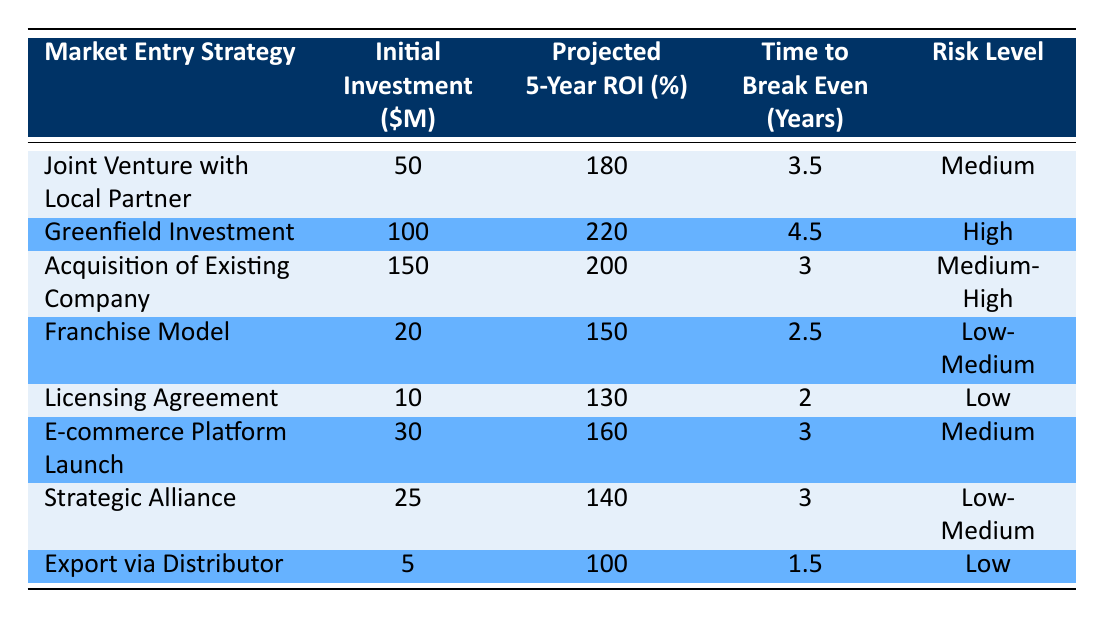What is the initial investment for a Joint Venture with Local Partner? The table shows that the initial investment for a Joint Venture with Local Partner is listed in the "Initial Investment ($M)" column, which states $50 million.
Answer: 50 million What is the projected ROI for the Greenfield Investment strategy? Referring to the "Projected 5-Year ROI (%)" column, the Greenfield Investment strategy has a projected ROI of 220%.
Answer: 220% Which market entry strategy has the lowest initial investment? By comparing the "Initial Investment ($M)" values across all strategies, the Export via Distributor has the lowest investment at $5 million.
Answer: Export via Distributor Is the time to break even for the Franchise Model less than 3 years? The time to break even for the Franchise Model is 2.5 years, which is indeed less than 3 years.
Answer: Yes What is the average projected ROI for all the strategies listed? To find the average projected ROI, we sum the projected ROIs: (180 + 220 + 200 + 150 + 130 + 160 + 140 + 100) = 1280, then divide by the number of strategies, which is 8: 1280 / 8 = 160.
Answer: 160 How many strategies have a risk level categorized as "Medium"? Looking through the "Risk Level" column, we find that two strategies, Joint Venture with Local Partner and E-commerce Platform Launch, are categorized as "Medium."
Answer: 2 What is the difference in projected ROI between the Greenfield Investment and the Franchise Model? The projected ROI for Greenfield Investment is 220% and for Franchise Model it is 150%. Calculating the difference: 220 - 150 = 70.
Answer: 70 Which strategy offers the highest projected ROI but has a time to break even of less than 4 years? Analyzing the "Projected 5-Year ROI (%)" and "Time to Break Even (Years)" columns, the Joint Venture with Local Partner provides a projected ROI of 180% with a break-even time of 3.5 years, which is the highest ROI under 4 years in break-even time.
Answer: Joint Venture with Local Partner 